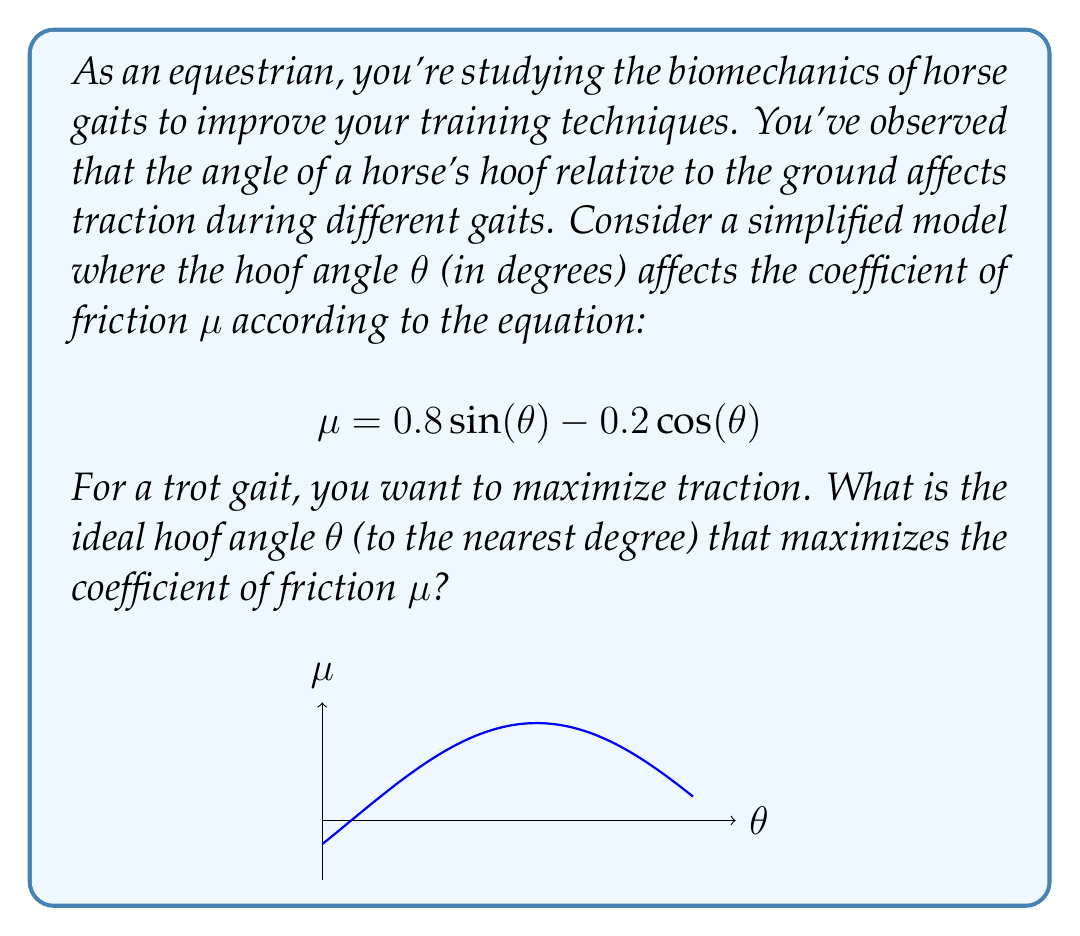Could you help me with this problem? To find the maximum value of μ, we need to differentiate the equation with respect to θ and set it to zero:

1) First, convert the equation to radians:
   $$μ = 0.8 \sin(\frac{π}{180}θ) - 0.2 \cos(\frac{π}{180}θ)$$

2) Differentiate μ with respect to θ:
   $$\frac{dμ}{dθ} = 0.8 \cdot \frac{π}{180} \cos(\frac{π}{180}θ) + 0.2 \cdot \frac{π}{180} \sin(\frac{π}{180}θ)$$

3) Set the derivative to zero and solve:
   $$0.8 \cos(\frac{π}{180}θ) + 0.2 \sin(\frac{π}{180}θ) = 0$$
   $$\tan(\frac{π}{180}θ) = -4$$

4) Solve for θ:
   $$θ = \frac{180}{π} \arctan(-4) \approx -75.96°$$

5) Since we're looking for a positive angle, we add 180°:
   $$θ \approx 104.04°$$

6) Rounding to the nearest degree:
   $$θ = 104°$$

To confirm this is a maximum, we can check the second derivative is negative at this point or observe the behavior of the function around this value.
Answer: 104° 